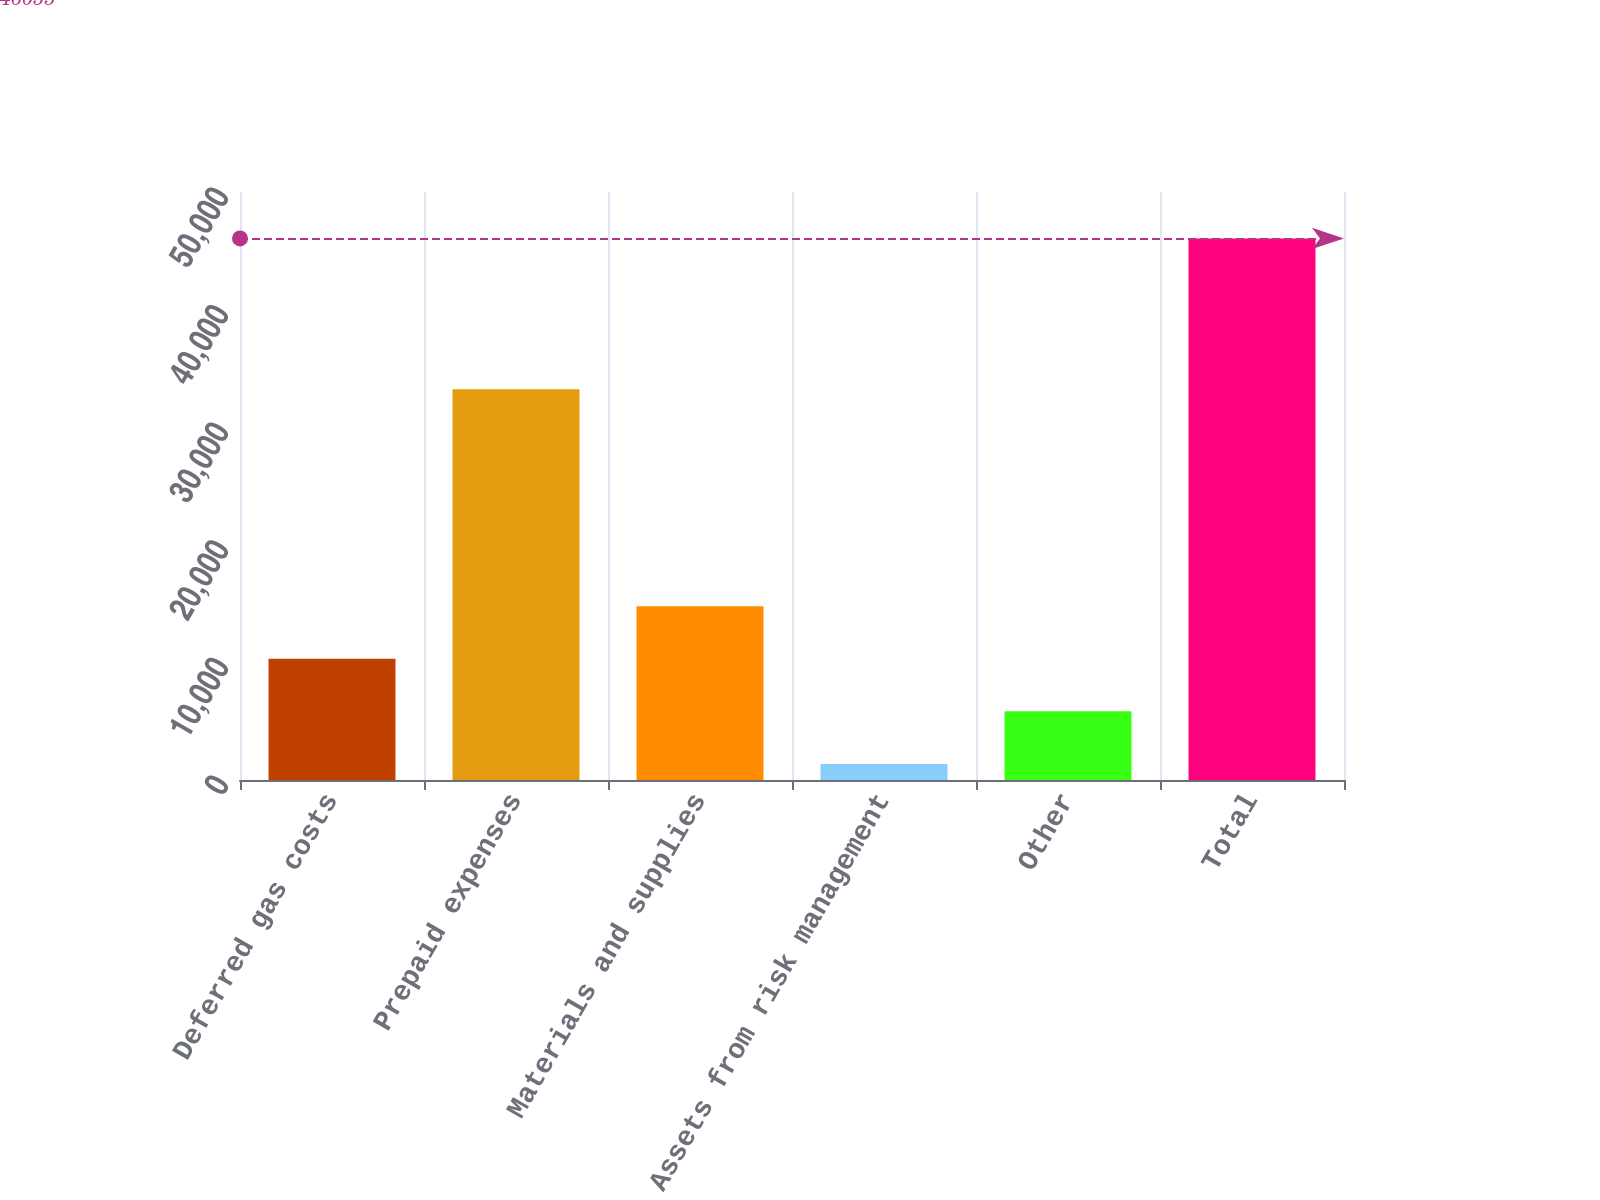Convert chart to OTSL. <chart><loc_0><loc_0><loc_500><loc_500><bar_chart><fcel>Deferred gas costs<fcel>Prepaid expenses<fcel>Materials and supplies<fcel>Assets from risk management<fcel>Other<fcel>Total<nl><fcel>10306.2<fcel>33233<fcel>14774.8<fcel>1369<fcel>5837.6<fcel>46055<nl></chart> 